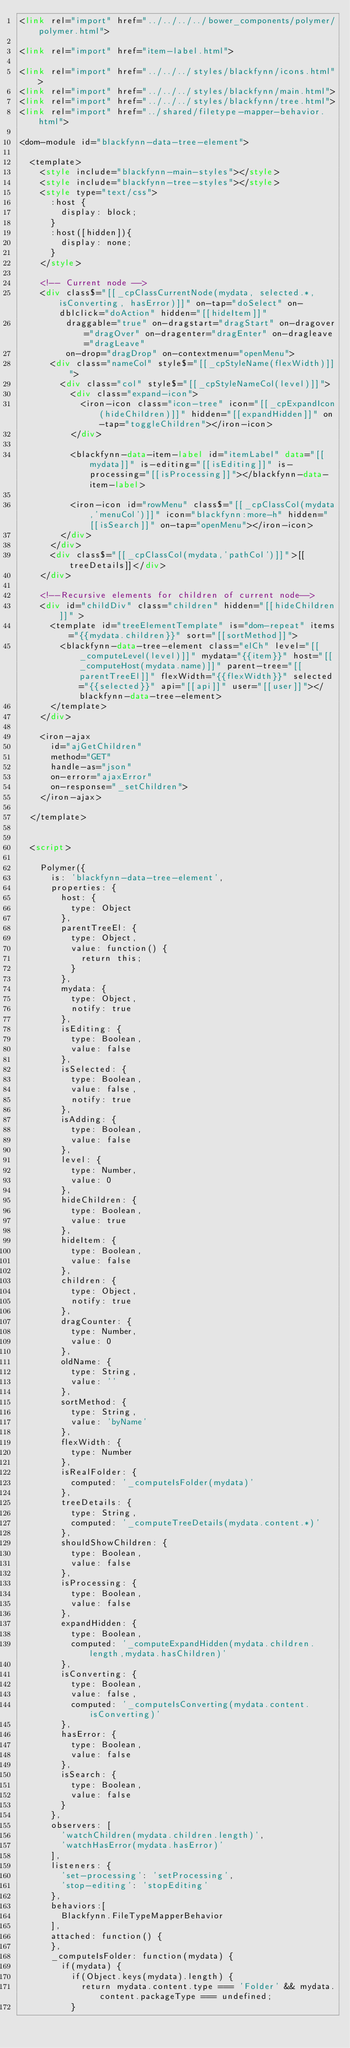Convert code to text. <code><loc_0><loc_0><loc_500><loc_500><_HTML_><link rel="import" href="../../../../bower_components/polymer/polymer.html">

<link rel="import" href="item-label.html">

<link rel="import" href="../../../styles/blackfynn/icons.html">
<link rel="import" href="../../../styles/blackfynn/main.html">
<link rel="import" href="../../../styles/blackfynn/tree.html">
<link rel="import" href="../shared/filetype-mapper-behavior.html">

<dom-module id="blackfynn-data-tree-element">

  <template>
    <style include="blackfynn-main-styles"></style>
    <style include="blackfynn-tree-styles"></style>
    <style type="text/css">
      :host {
        display: block;
      }
      :host([hidden]){
        display: none;
      }
    </style>

    <!-- Current node -->
    <div class$="[[_cpClassCurrentNode(mydata, selected.*, isConverting, hasError)]]" on-tap="doSelect" on-dblclick="doAction" hidden="[[hideItem]]"
         draggable="true" on-dragstart="dragStart" on-dragover="dragOver" on-dragenter="dragEnter" on-dragleave="dragLeave"
         on-drop="dragDrop" on-contextmenu="openMenu">
      <div class="nameCol" style$="[[_cpStyleName(flexWidth)]]">
        <div class="col" style$="[[_cpStyleNameCol(level)]]">
          <div class="expand-icon">
            <iron-icon class="icon-tree" icon="[[_cpExpandIcon(hideChildren)]]" hidden="[[expandHidden]]" on-tap="toggleChildren"></iron-icon>
          </div>

          <blackfynn-data-item-label id="itemLabel" data="[[mydata]]" is-editing="[[isEditing]]" is-processing="[[isProcessing]]"></blackfynn-data-item-label>

          <iron-icon id="rowMenu" class$="[[_cpClassCol(mydata,'menuCol')]]" icon="blackfynn:more-h" hidden="[[isSearch]]" on-tap="openMenu"></iron-icon>
        </div>
      </div>
      <div class$="[[_cpClassCol(mydata,'pathCol')]]">[[treeDetails]]</div>
    </div>

    <!--Recursive elements for children of current node-->
    <div id="childDiv" class="children" hidden="[[hideChildren]]" >
      <template id="treeElementTemplate" is="dom-repeat" items="{{mydata.children}}" sort="[[sortMethod]]">
        <blackfynn-data-tree-element class="elCh" level="[[_computeLevel(level)]]" mydata="{{item}}" host="[[_computeHost(mydata.name)]]" parent-tree="[[parentTreeEl]]" flexWidth="{{flexWidth}}" selected="{{selected}}" api="[[api]]" user="[[user]]"></blackfynn-data-tree-element>
      </template>
    </div>

    <iron-ajax
      id="ajGetChildren"
      method="GET"
      handle-as="json"
      on-error="ajaxError"
      on-response="_setChildren">
    </iron-ajax>

  </template>


  <script>

    Polymer({
      is: 'blackfynn-data-tree-element',
      properties: {
        host: {
          type: Object
        },
        parentTreeEl: {
          type: Object,
          value: function() {
            return this;
          }
        },
        mydata: {
          type: Object,
          notify: true
        },
        isEditing: {
          type: Boolean,
          value: false
        },
        isSelected: {
          type: Boolean,
          value: false,
          notify: true
        },
        isAdding: {
          type: Boolean,
          value: false
        },
        level: {
          type: Number,
          value: 0
        },
        hideChildren: {
          type: Boolean,
          value: true
        },
        hideItem: {
          type: Boolean,
          value: false
        },
        children: {
          type: Object,
          notify: true
        },
        dragCounter: {
          type: Number,
          value: 0
        },
        oldName: {
          type: String,
          value: ''
        },
        sortMethod: {
          type: String,
          value: 'byName'
        },
        flexWidth: {
          type: Number
        },
        isRealFolder: {
          computed: '_computeIsFolder(mydata)'
        },
        treeDetails: {
          type: String,
          computed: '_computeTreeDetails(mydata.content.*)'
        },
        shouldShowChildren: {
          type: Boolean,
          value: false
        },
        isProcessing: {
          type: Boolean,
          value: false
        },
        expandHidden: {
          type: Boolean,
          computed: '_computeExpandHidden(mydata.children.length,mydata.hasChildren)'
        },
        isConverting: {
          type: Boolean,
          value: false,
          computed: '_computeIsConverting(mydata.content.isConverting)'
        },
        hasError: {
          type: Boolean,
          value: false
        },
        isSearch: {
          type: Boolean,
          value: false
        }
      },
      observers: [
        'watchChildren(mydata.children.length)',
        'watchHasError(mydata.hasError)'
      ],
      listeners: {
        'set-processing': 'setProcessing',
        'stop-editing': 'stopEditing'
      },
      behaviors:[
        Blackfynn.FileTypeMapperBehavior
      ],
      attached: function() {
      },
      _computeIsFolder: function(mydata) {
        if(mydata) {
          if(Object.keys(mydata).length) {
            return mydata.content.type === 'Folder' && mydata.content.packageType === undefined;
          }</code> 